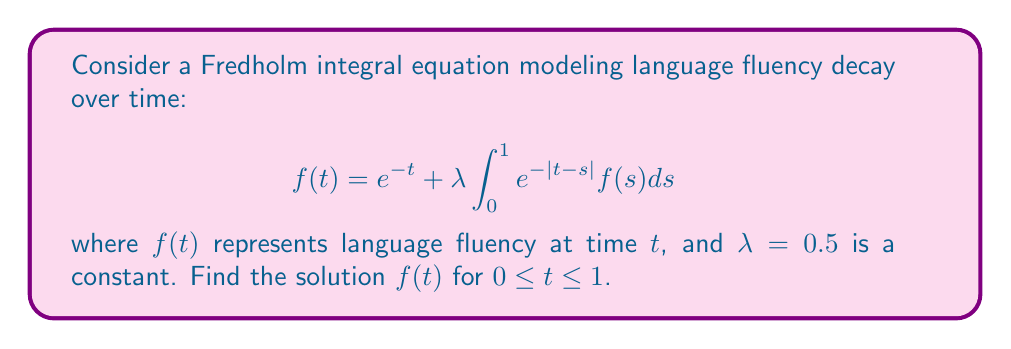Give your solution to this math problem. 1. We'll solve this using the method of resolvent kernels. First, rewrite the equation in standard form:

   $$f(t) = g(t) + \lambda \int_0^1 K(t,s) f(s) ds$$

   where $g(t) = e^{-t}$ and $K(t,s) = e^{-|t-s|}$

2. The resolvent kernel $R(t,s,\lambda)$ satisfies:

   $$R(t,s,\lambda) = K(t,s) + \lambda \int_0^1 K(t,u) R(u,s,\lambda) du$$

3. For this symmetric kernel, we can use the ansatz:

   $$R(t,s,\lambda) = A e^{-|t-s|} + B (e^{-t-s} + e^{t+s-2})$$

4. Substitute this into the resolvent equation and equate coefficients:

   $$A = 1 + \lambda A - 2\lambda B$$
   $$B = \lambda B$$

5. Solve for $A$ and $B$:

   $$B = 0$$
   $$A = \frac{1}{1-\lambda} = 2$$

6. The solution is given by:

   $$f(t) = g(t) + \lambda \int_0^1 R(t,s,\lambda) g(s) ds$$

7. Substitute and evaluate:

   $$f(t) = e^{-t} + 0.5 \int_0^1 (2e^{-|t-s|}) e^{-s} ds$$

8. Simplify and integrate:

   $$f(t) = e^{-t} + e^{-t} \int_0^t e^s ds + e^t \int_t^1 e^{-2s} ds$$

9. Evaluate the integrals:

   $$f(t) = e^{-t} + e^{-t} (e^t - 1) + e^t (\frac{e^{-2t} - e^{-2}}{2})$$

10. Simplify to get the final solution:

    $$f(t) = 2 - \frac{1}{2}e^{-t} - \frac{1}{2}e^{t-2}$$
Answer: $f(t) = 2 - \frac{1}{2}e^{-t} - \frac{1}{2}e^{t-2}$ 